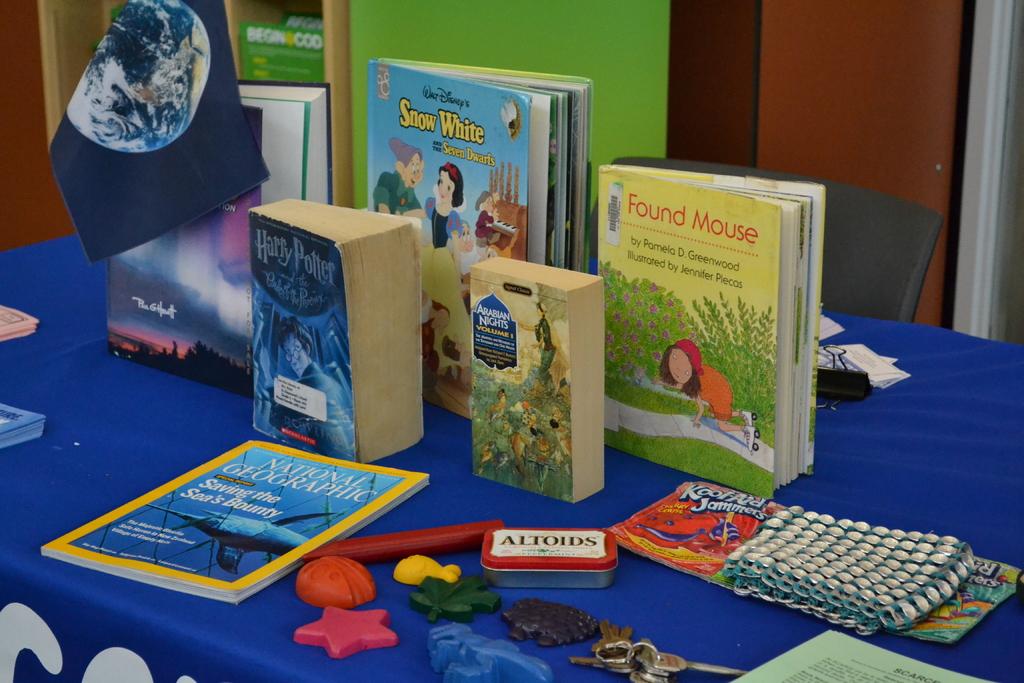What are the titles of these books?
Give a very brief answer. Snow white, harry potter, found mouse. What type of breath-mint is in the tin on the table?
Provide a succinct answer. Altoids. 